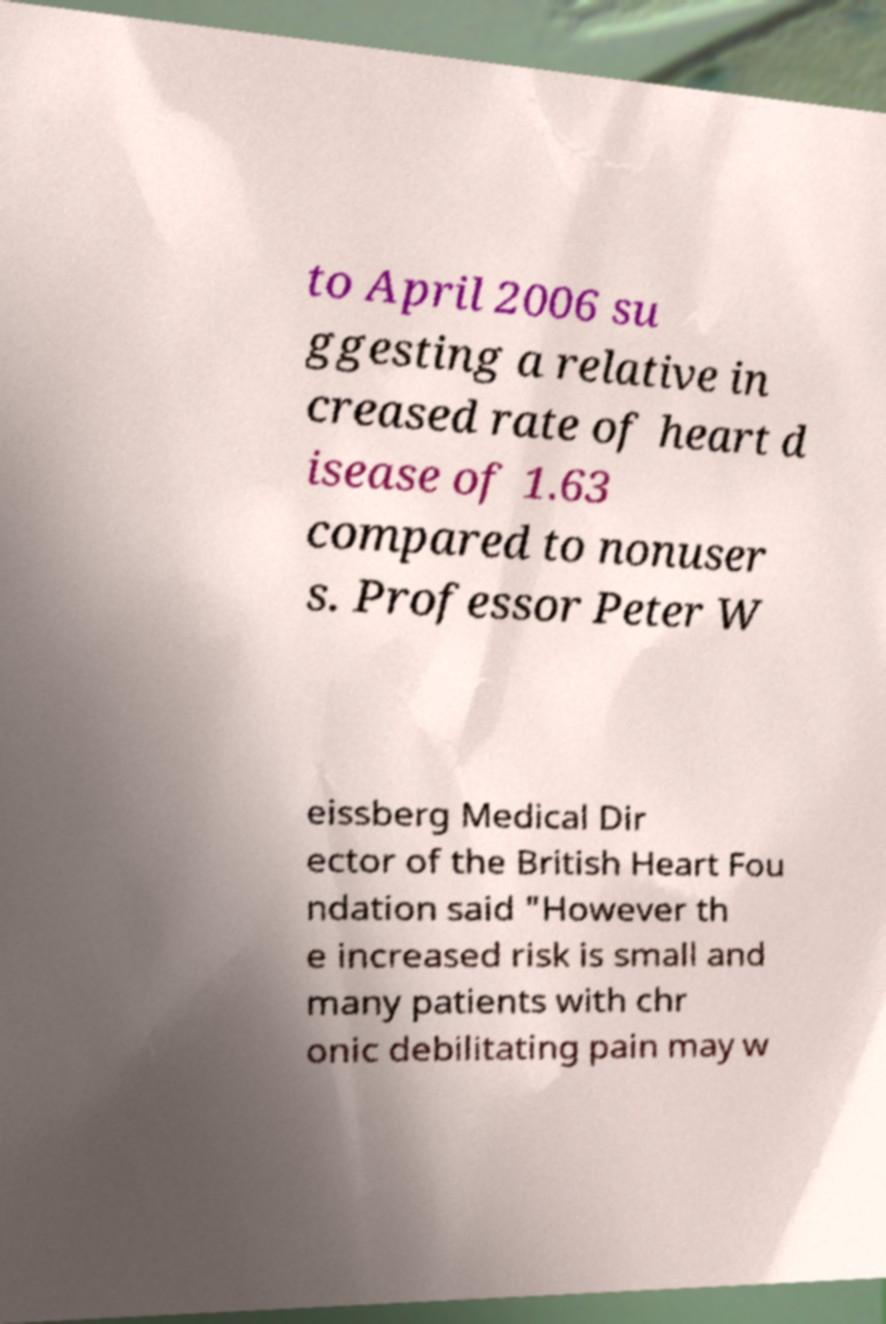What messages or text are displayed in this image? I need them in a readable, typed format. to April 2006 su ggesting a relative in creased rate of heart d isease of 1.63 compared to nonuser s. Professor Peter W eissberg Medical Dir ector of the British Heart Fou ndation said "However th e increased risk is small and many patients with chr onic debilitating pain may w 